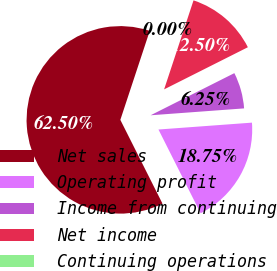<chart> <loc_0><loc_0><loc_500><loc_500><pie_chart><fcel>Net sales<fcel>Operating profit<fcel>Income from continuing<fcel>Net income<fcel>Continuing operations<nl><fcel>62.5%<fcel>18.75%<fcel>6.25%<fcel>12.5%<fcel>0.0%<nl></chart> 